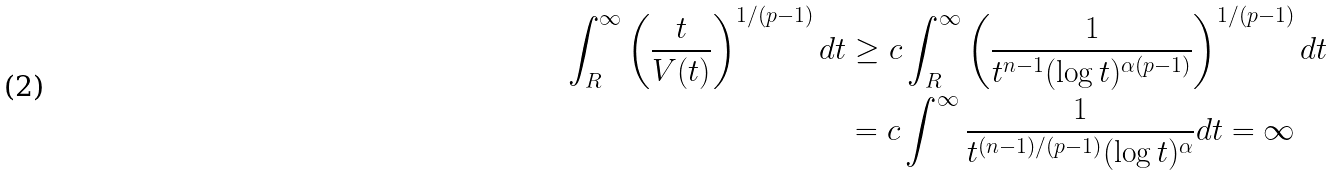<formula> <loc_0><loc_0><loc_500><loc_500>\int _ { R } ^ { \infty } \left ( \frac { t } { V ( t ) } \right ) ^ { 1 / ( p - 1 ) } d t & \geq c \int _ { R } ^ { \infty } \left ( \frac { 1 } { t ^ { n - 1 } ( \log t ) ^ { \alpha ( p - 1 ) } } \right ) ^ { 1 / ( p - 1 ) } d t \\ & = c \int ^ { \infty } \frac { 1 } { t ^ { ( n - 1 ) / ( p - 1 ) } ( \log t ) ^ { \alpha } } d t = \infty</formula> 